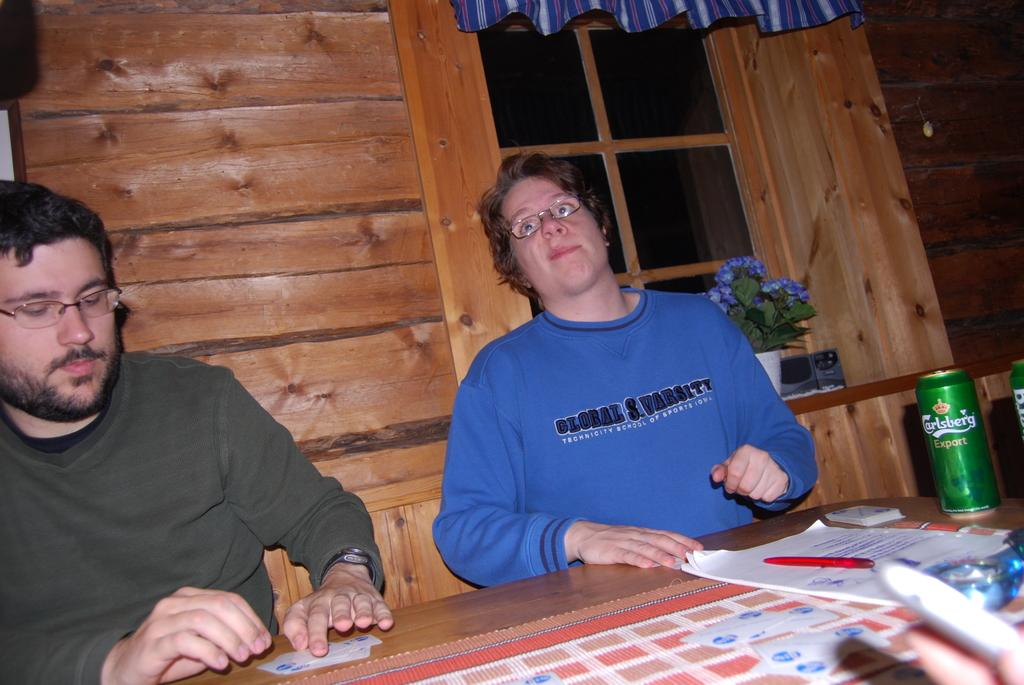How many people are in the image? There is a man and a woman in the image. What are the man and woman doing in the image? They are standing in front of a table. What is on the table in the image? There is a book and a can on the table. Can you describe the book on the table? The book is open. What can be seen in the background of the image? There is a wall, a window, and a plant in a pot in the background of the image. Where is the shelf located in the image? There is no shelf present in the image. What type of plough is being used by the man in the image? There is no plough present in the image, and the man is not performing any agricultural activities. 